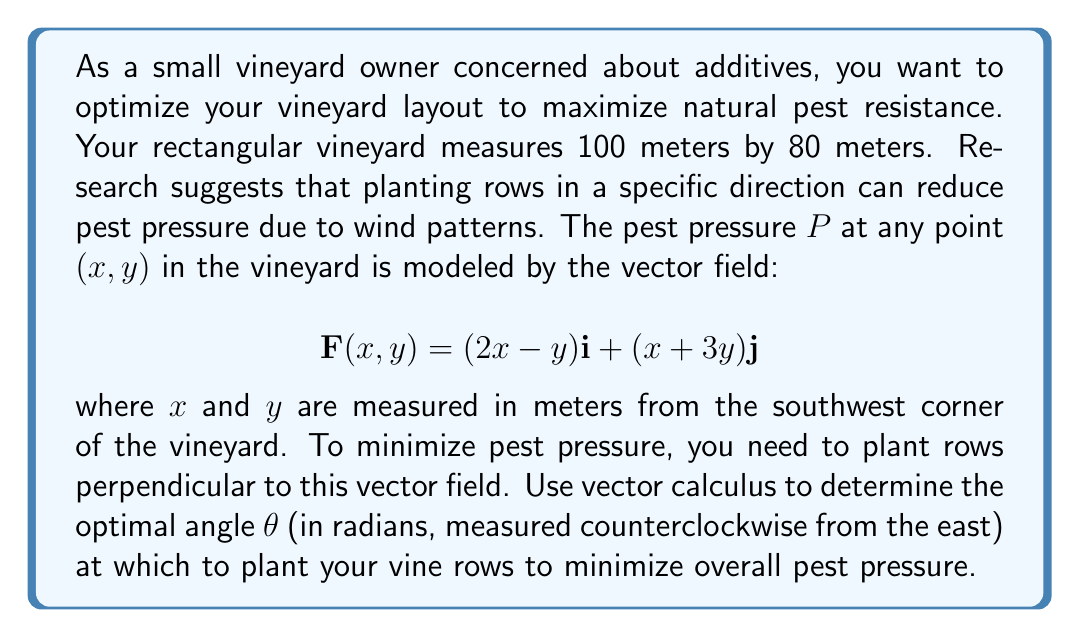Provide a solution to this math problem. To solve this problem, we'll use the principles of vector calculus:

1) The vector field $\mathbf{F}(x,y) = (2x-y)\mathbf{i} + (x+3y)\mathbf{j}$ represents the pest pressure at each point.

2) To minimize pest pressure, we want to plant rows perpendicular to this vector field. The direction of the rows should be orthogonal to the average direction of $\mathbf{F}$.

3) To find the average direction, we need to integrate $\mathbf{F}$ over the entire vineyard and then normalize the result:

   $$\mathbf{F}_{avg} = \frac{1}{A}\int_0^{80}\int_0^{100} \mathbf{F}(x,y) \,dx\,dy$$

   where $A = 80 * 100 = 8000$ m² is the area of the vineyard.

4) Let's integrate each component separately:

   For the $x$-component:
   $$\frac{1}{8000}\int_0^{80}\int_0^{100} (2x-y) \,dx\,dy = \frac{1}{8000}[100x^2 - 100xy]_0^{80} = 50$$

   For the $y$-component:
   $$\frac{1}{8000}\int_0^{80}\int_0^{100} (x+3y) \,dx\,dy = \frac{1}{8000}[100x + 150y^2]_0^{80} = 130$$

5) So, $\mathbf{F}_{avg} = 50\mathbf{i} + 130\mathbf{j}$

6) The optimal planting direction should be perpendicular to this. We can find it by rotating $\mathbf{F}_{avg}$ by 90° counterclockwise:

   $$\mathbf{R} = -130\mathbf{i} + 50\mathbf{j}$$

7) The angle θ this vector makes with the positive x-axis (east) is:

   $$\theta = \arctan(\frac{50}{-130}) + \pi = \arctan(-\frac{5}{13}) + \pi$$

8) Evaluating this expression:

   $$\theta \approx 2.7653 \text{ radians}$$
Answer: The optimal angle to plant the vine rows is approximately 2.7653 radians (or about 158.4 degrees) counterclockwise from the east. 